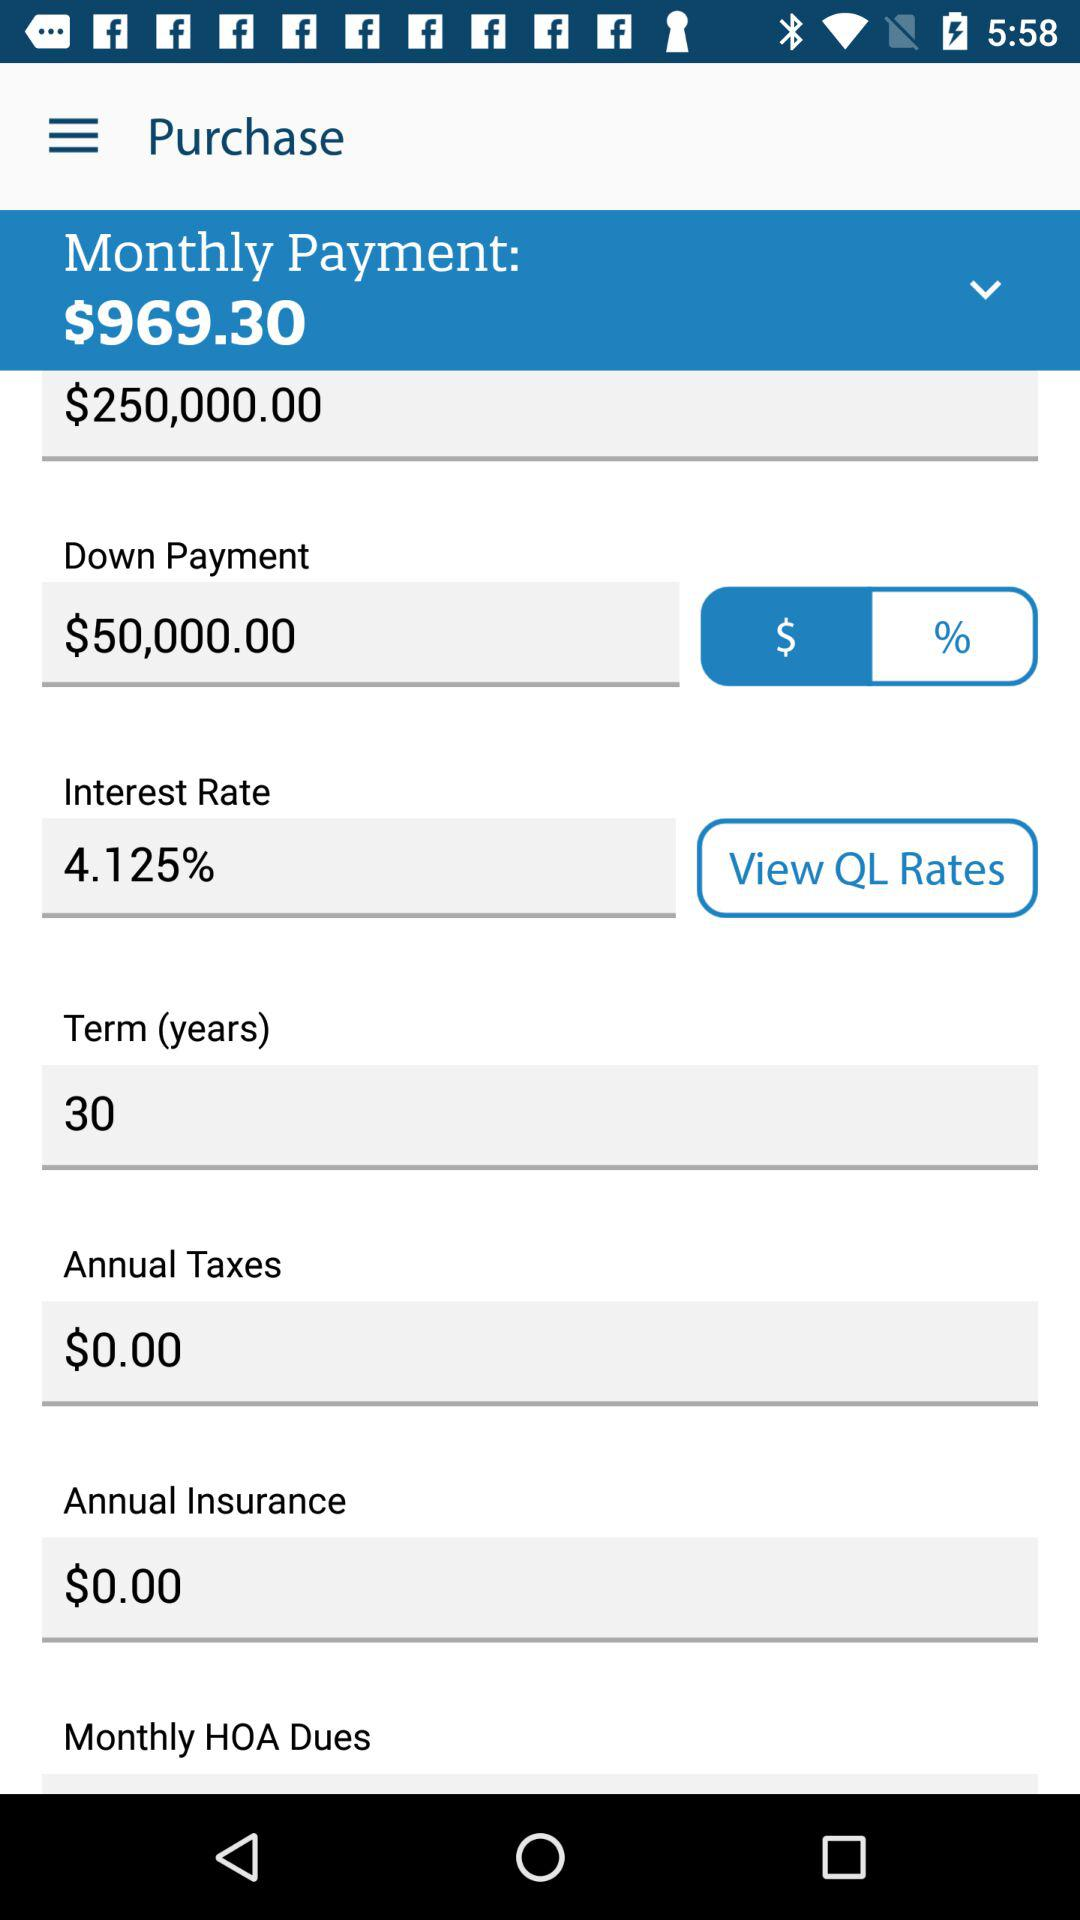What is the term in years? The term in years is 30. 